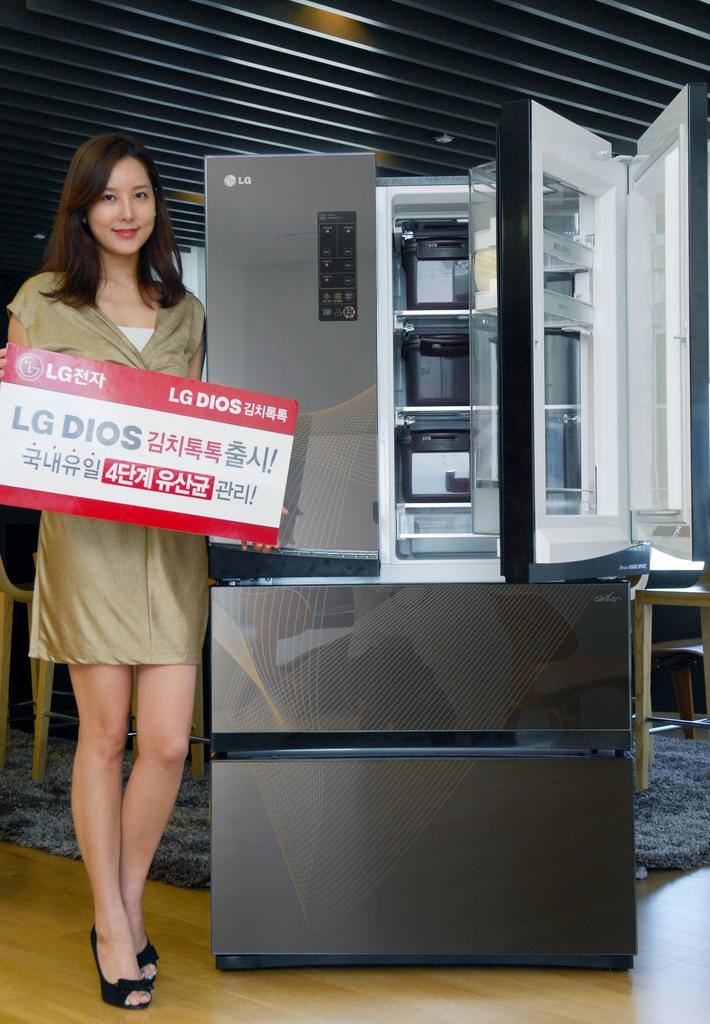Provide a one-sentence caption for the provided image. A model stands in front of an silver LG refrigerator. 